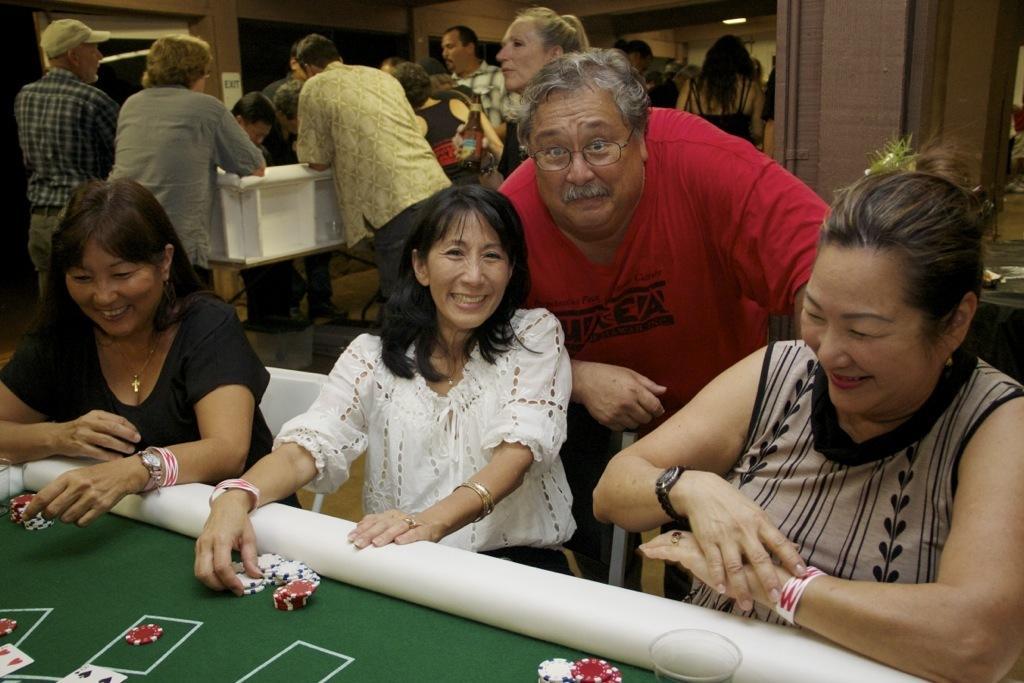How would you summarize this image in a sentence or two? This picture is taken in a club. In the foreground of the picture there is a board, on the board there are coins and cards and a glass. In the center of the picture there are many people standing and few are sitting. On the right there is a wall. On the background there are doors and ceiling lights. 